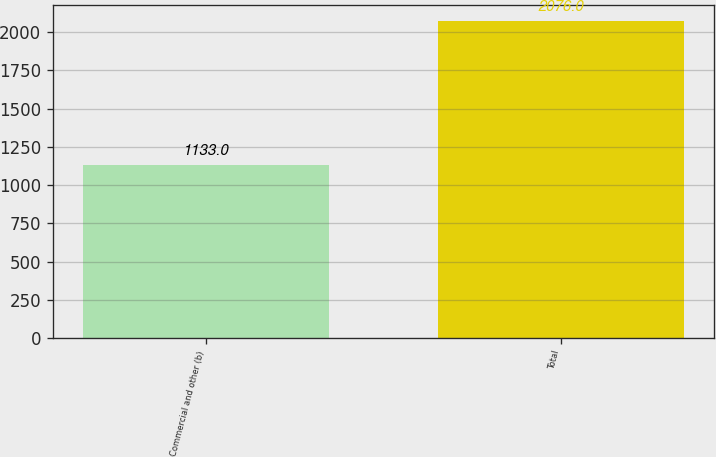<chart> <loc_0><loc_0><loc_500><loc_500><bar_chart><fcel>Commercial and other (b)<fcel>Total<nl><fcel>1133<fcel>2076<nl></chart> 